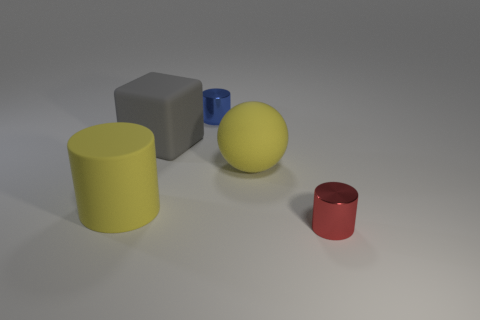Is the number of large cubes that are behind the gray cube the same as the number of blue cylinders?
Keep it short and to the point. No. Is the size of the rubber cylinder the same as the blue metal object?
Provide a succinct answer. No. How many shiny objects are either cylinders or blue cylinders?
Your answer should be very brief. 2. What is the material of the yellow cylinder that is the same size as the gray rubber thing?
Offer a very short reply. Rubber. How many other objects are there of the same material as the small red cylinder?
Your answer should be very brief. 1. Are there fewer shiny cylinders that are to the right of the tiny red object than yellow matte cylinders?
Your answer should be very brief. Yes. Does the blue thing have the same shape as the large gray thing?
Your answer should be very brief. No. What is the size of the metallic cylinder behind the matte cube left of the metallic thing in front of the gray matte cube?
Your response must be concise. Small. What is the material of the other large object that is the same shape as the red metallic thing?
Your answer should be very brief. Rubber. There is a yellow matte object in front of the large yellow matte object to the right of the small blue metal thing; how big is it?
Offer a very short reply. Large. 